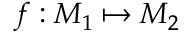Convert formula to latex. <formula><loc_0><loc_0><loc_500><loc_500>f \colon M _ { 1 } \mapsto M _ { 2 }</formula> 